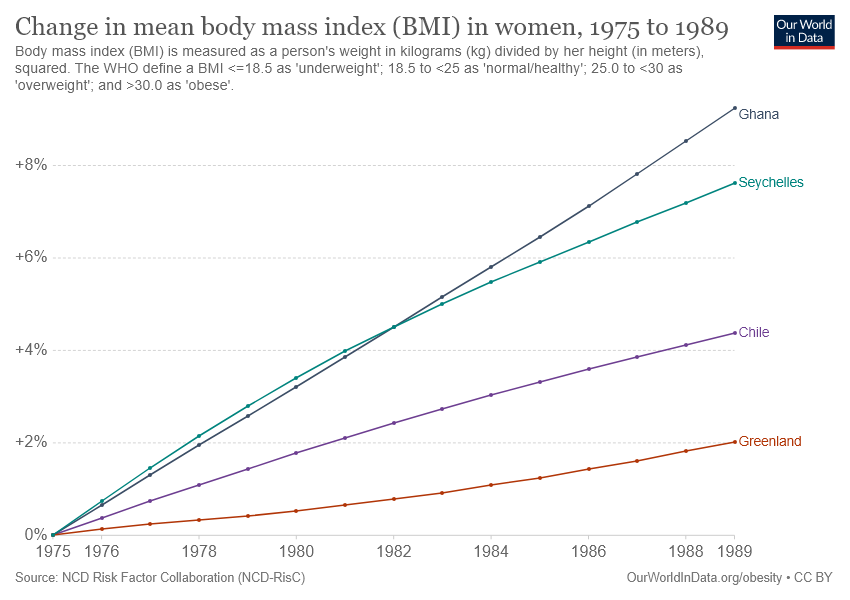Identify some key points in this picture. The mean body mass index in women in Chile changed by more than 4% over a period of years. The country with the highest increase in the mean body mass index of women over the years is Ghana. 